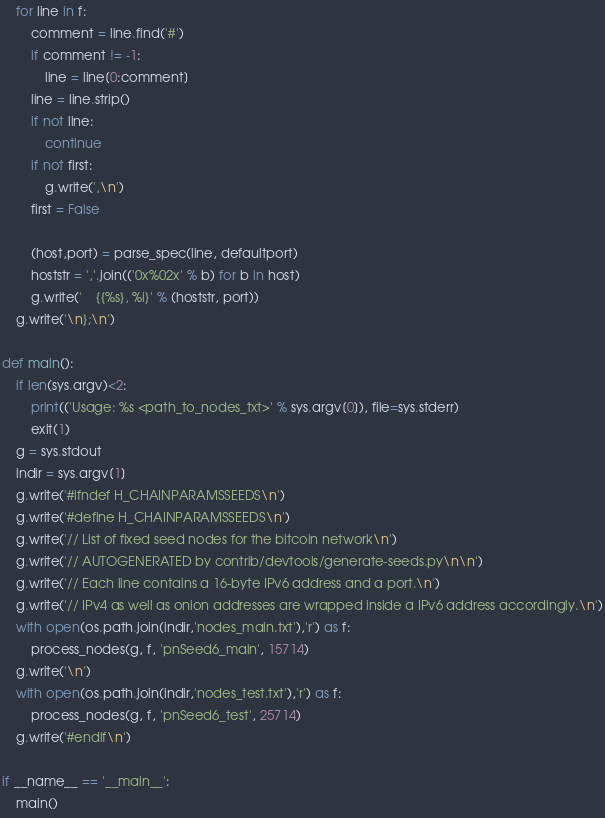<code> <loc_0><loc_0><loc_500><loc_500><_Python_>    for line in f:
        comment = line.find('#')
        if comment != -1:
            line = line[0:comment]
        line = line.strip()
        if not line:
            continue
        if not first:
            g.write(',\n')
        first = False

        (host,port) = parse_spec(line, defaultport)
        hoststr = ','.join(('0x%02x' % b) for b in host)
        g.write('    {{%s}, %i}' % (hoststr, port))
    g.write('\n};\n')

def main():
    if len(sys.argv)<2:
        print(('Usage: %s <path_to_nodes_txt>' % sys.argv[0]), file=sys.stderr)
        exit(1)
    g = sys.stdout
    indir = sys.argv[1]
    g.write('#ifndef H_CHAINPARAMSSEEDS\n')
    g.write('#define H_CHAINPARAMSSEEDS\n')
    g.write('// List of fixed seed nodes for the bitcoin network\n')
    g.write('// AUTOGENERATED by contrib/devtools/generate-seeds.py\n\n')
    g.write('// Each line contains a 16-byte IPv6 address and a port.\n')
    g.write('// IPv4 as well as onion addresses are wrapped inside a IPv6 address accordingly.\n')
    with open(os.path.join(indir,'nodes_main.txt'),'r') as f:
        process_nodes(g, f, 'pnSeed6_main', 15714)
    g.write('\n')
    with open(os.path.join(indir,'nodes_test.txt'),'r') as f:
        process_nodes(g, f, 'pnSeed6_test', 25714)
    g.write('#endif\n')

if __name__ == '__main__':
    main()
</code> 